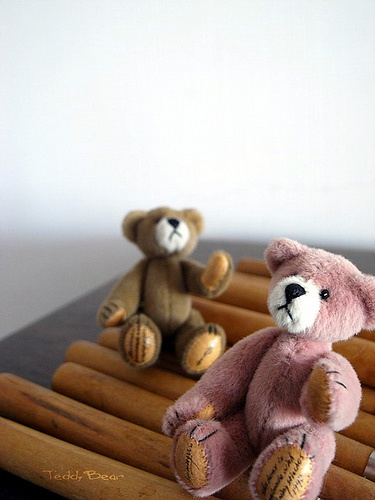Describe the objects in this image and their specific colors. I can see teddy bear in lightgray, maroon, gray, and lightpink tones and teddy bear in lightgray, black, maroon, and gray tones in this image. 